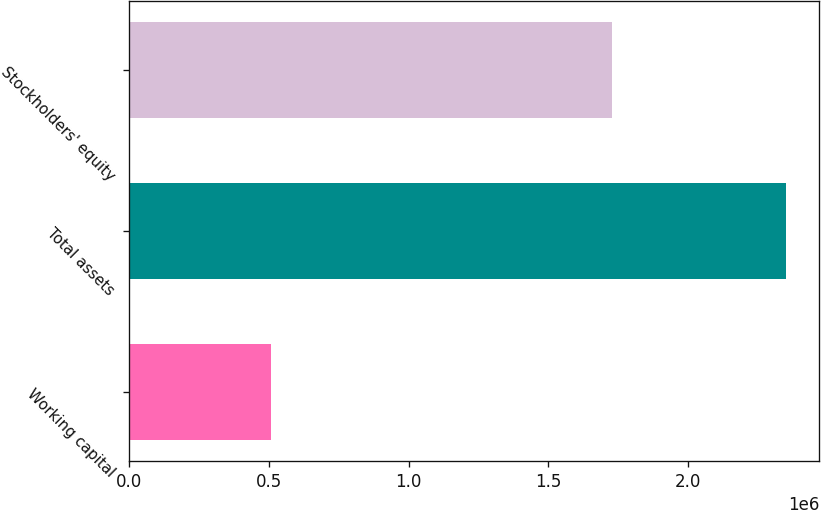Convert chart. <chart><loc_0><loc_0><loc_500><loc_500><bar_chart><fcel>Working capital<fcel>Total assets<fcel>Stockholders' equity<nl><fcel>509860<fcel>2.3506e+06<fcel>1.72619e+06<nl></chart> 